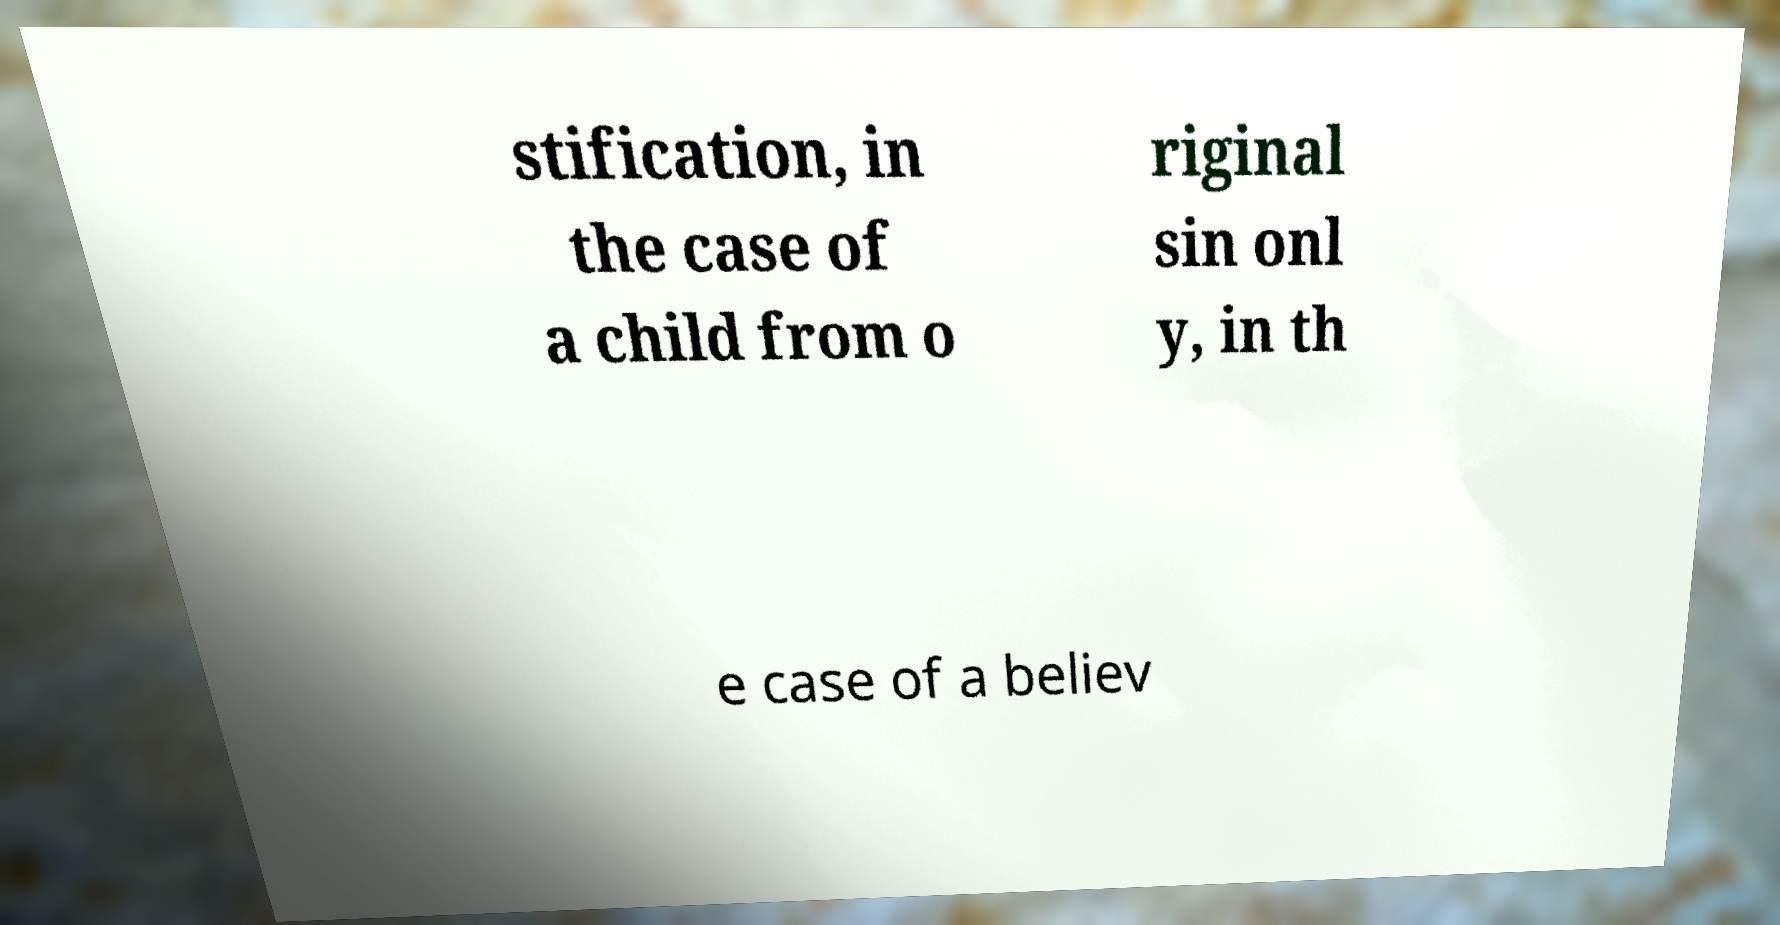For documentation purposes, I need the text within this image transcribed. Could you provide that? stification, in the case of a child from o riginal sin onl y, in th e case of a believ 